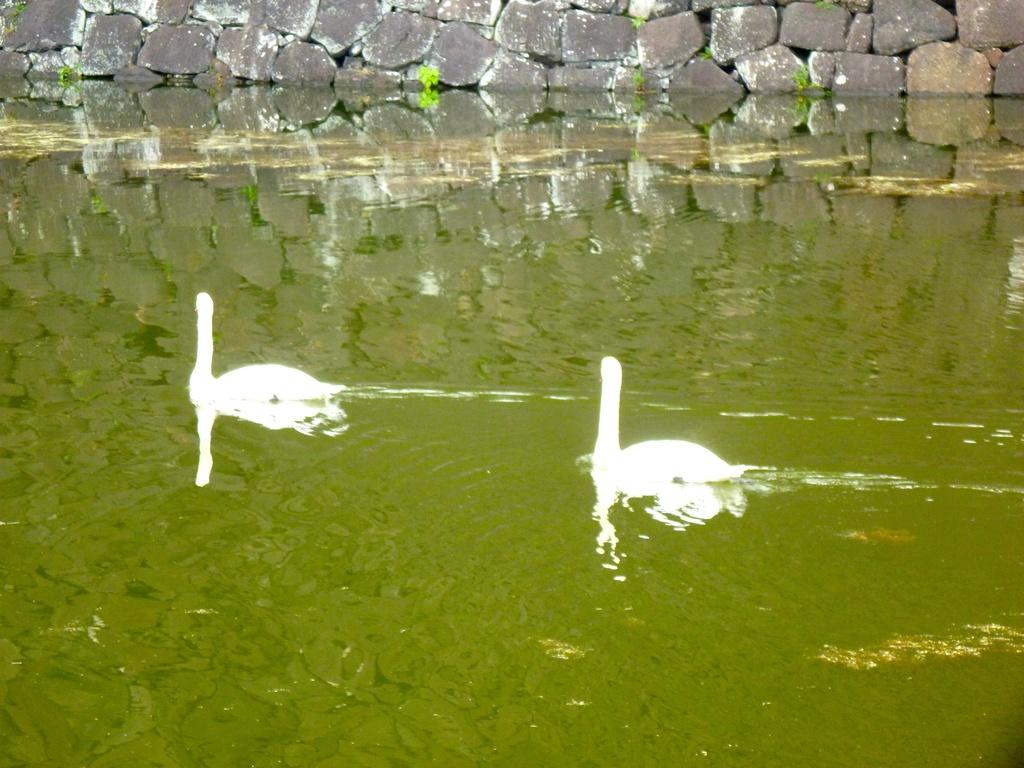What animals are on the water in the image? There are swans on the water in the image. What can be seen in the background of the image? There are plants and rocks in the background of the image. Can you see any mice playing on the swans in the image? There are no mice present in the image, and the swans are not interacting with any other animals. 